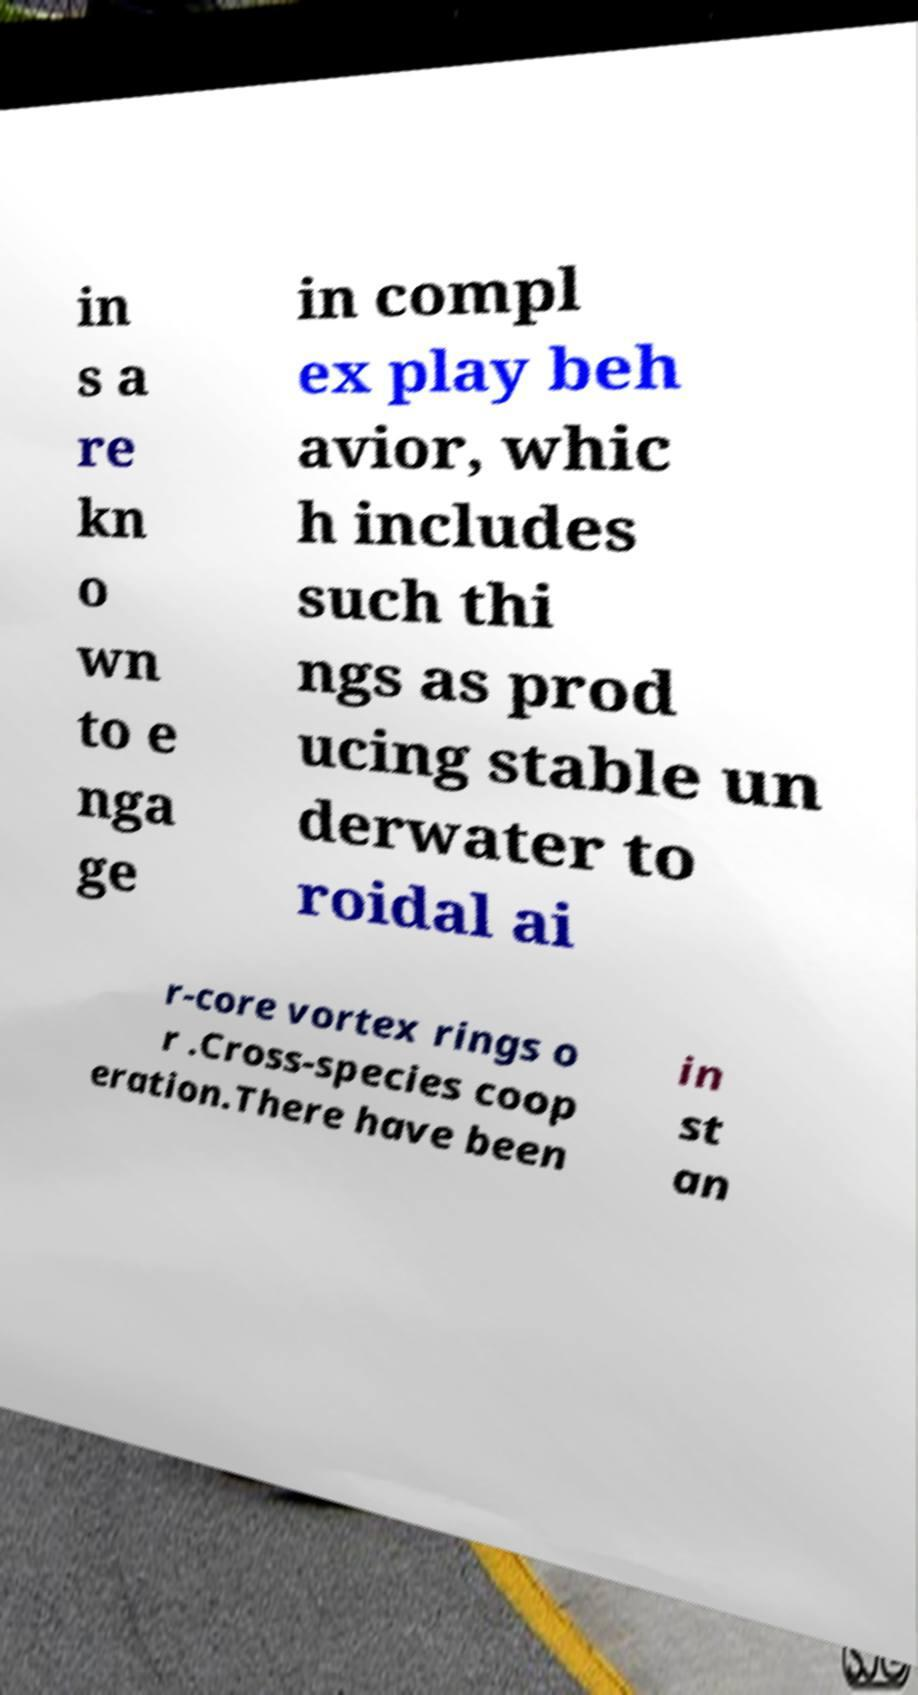There's text embedded in this image that I need extracted. Can you transcribe it verbatim? in s a re kn o wn to e nga ge in compl ex play beh avior, whic h includes such thi ngs as prod ucing stable un derwater to roidal ai r-core vortex rings o r .Cross-species coop eration.There have been in st an 